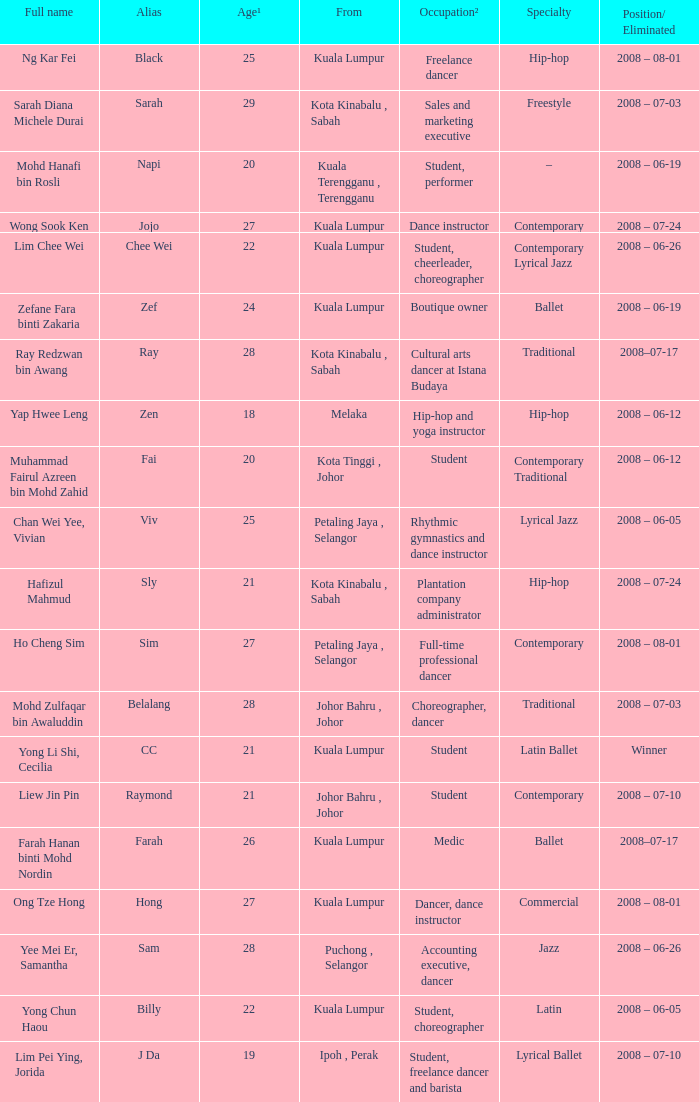When age¹ is more than 24 and alias is "black", what does occupation² equal? Freelance dancer. 